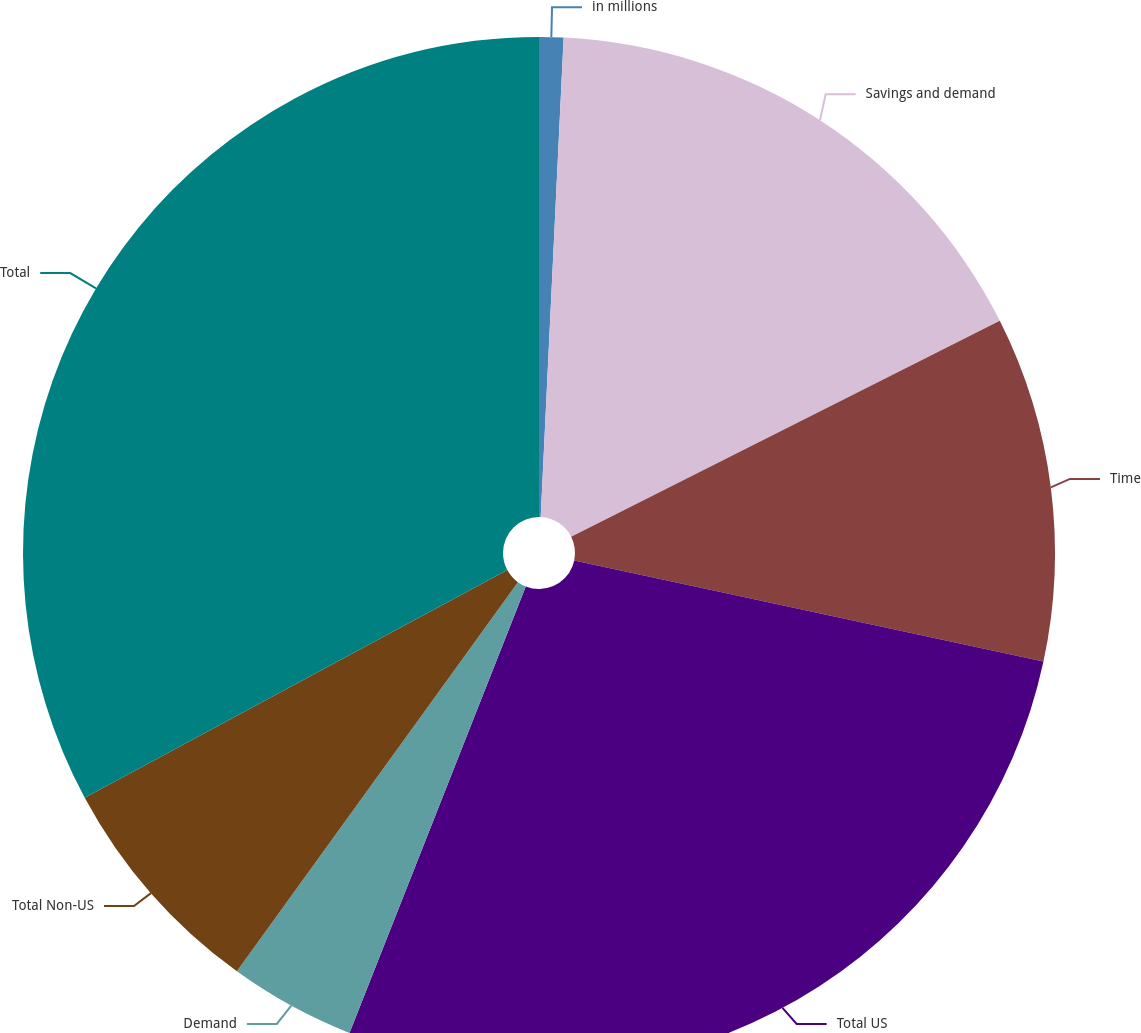<chart> <loc_0><loc_0><loc_500><loc_500><pie_chart><fcel>in millions<fcel>Savings and demand<fcel>Time<fcel>Total US<fcel>Demand<fcel>Total Non-US<fcel>Total<nl><fcel>0.76%<fcel>16.81%<fcel>10.8%<fcel>27.61%<fcel>3.97%<fcel>7.18%<fcel>32.86%<nl></chart> 